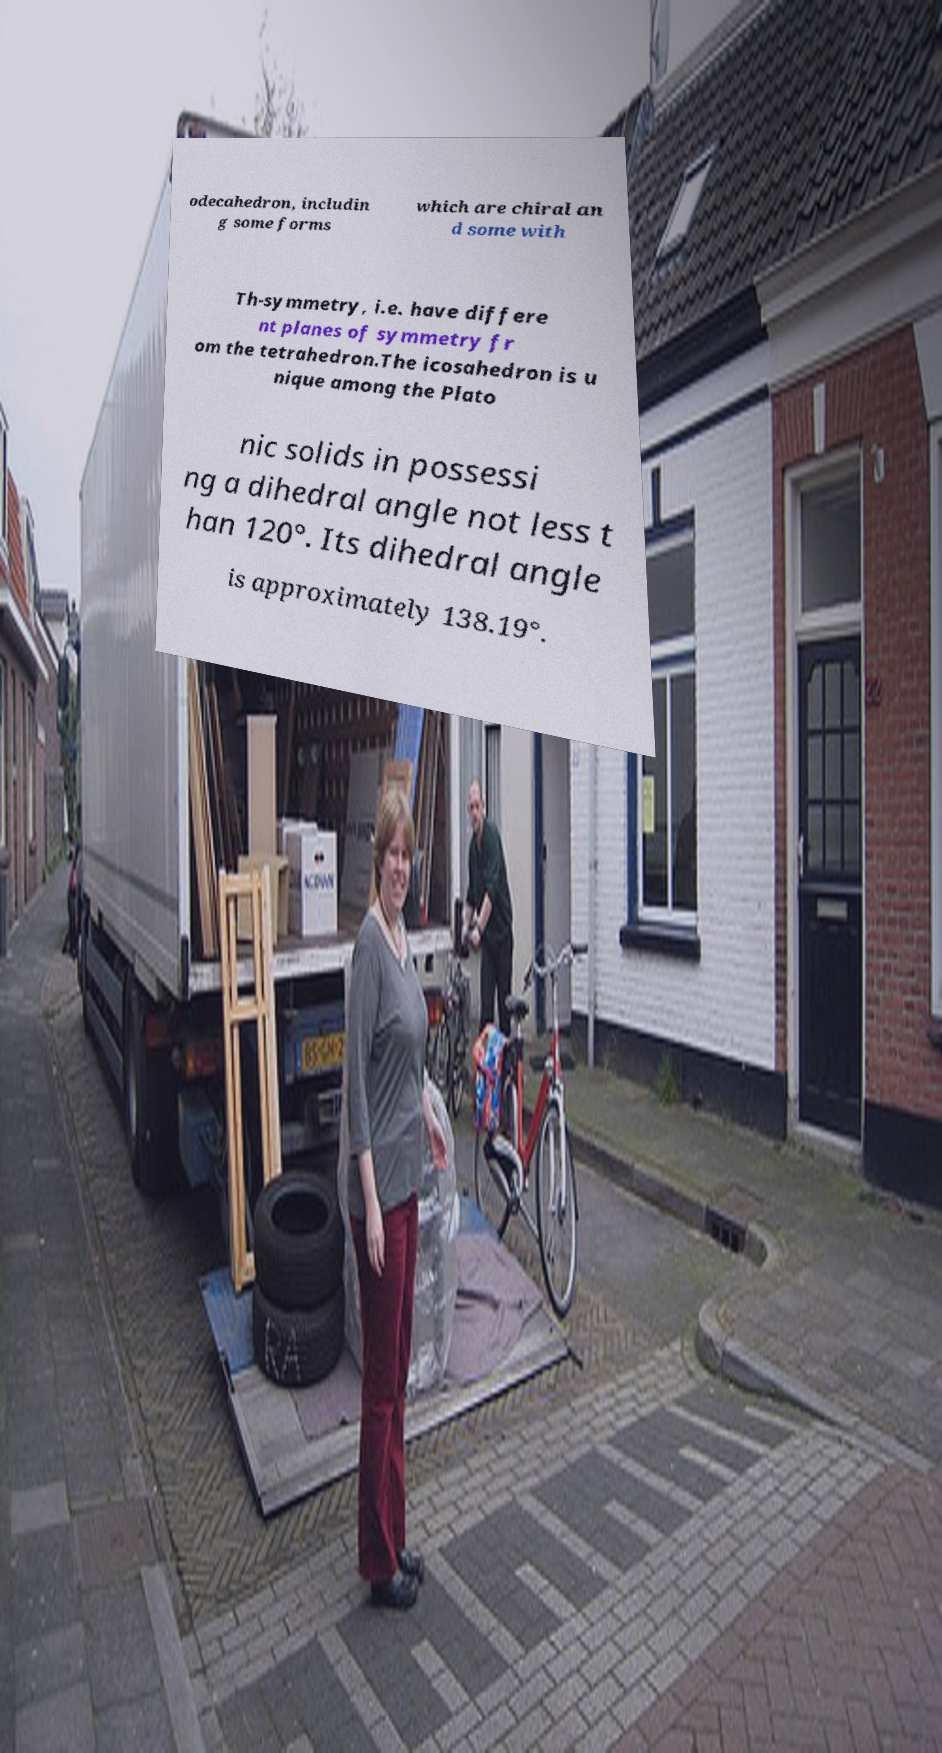Please read and relay the text visible in this image. What does it say? odecahedron, includin g some forms which are chiral an d some with Th-symmetry, i.e. have differe nt planes of symmetry fr om the tetrahedron.The icosahedron is u nique among the Plato nic solids in possessi ng a dihedral angle not less t han 120°. Its dihedral angle is approximately 138.19°. 